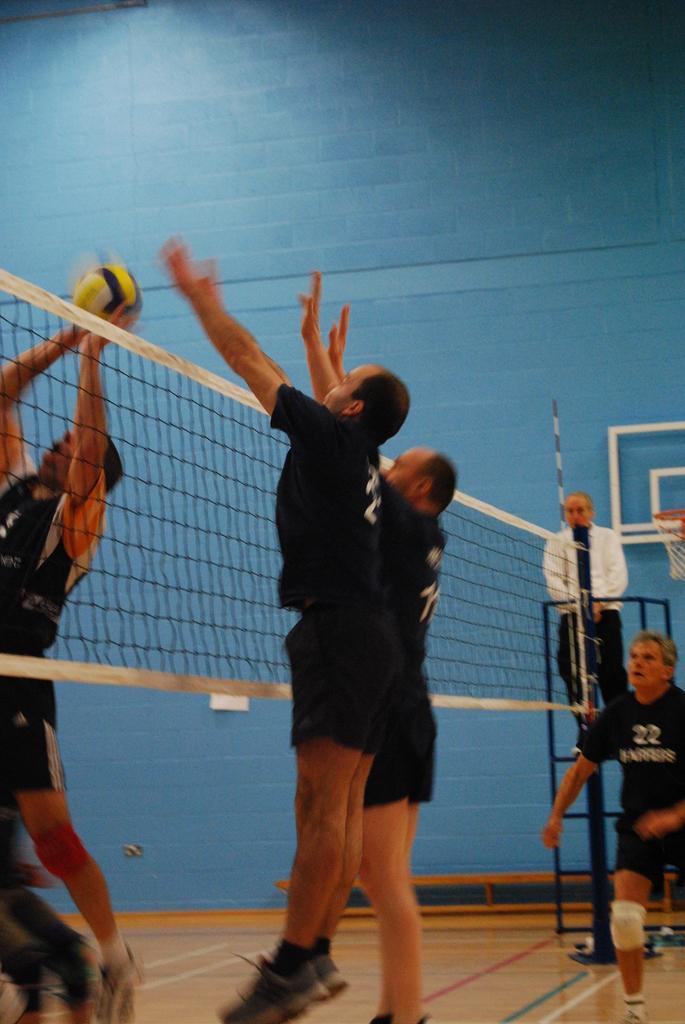How would you summarize this image in a sentence or two? In the center of the image there are people playing volleyball there is a net. In the background of the image there is wall. 